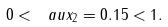<formula> <loc_0><loc_0><loc_500><loc_500>0 < \ a u x _ { 2 } = 0 . 1 5 < 1 .</formula> 